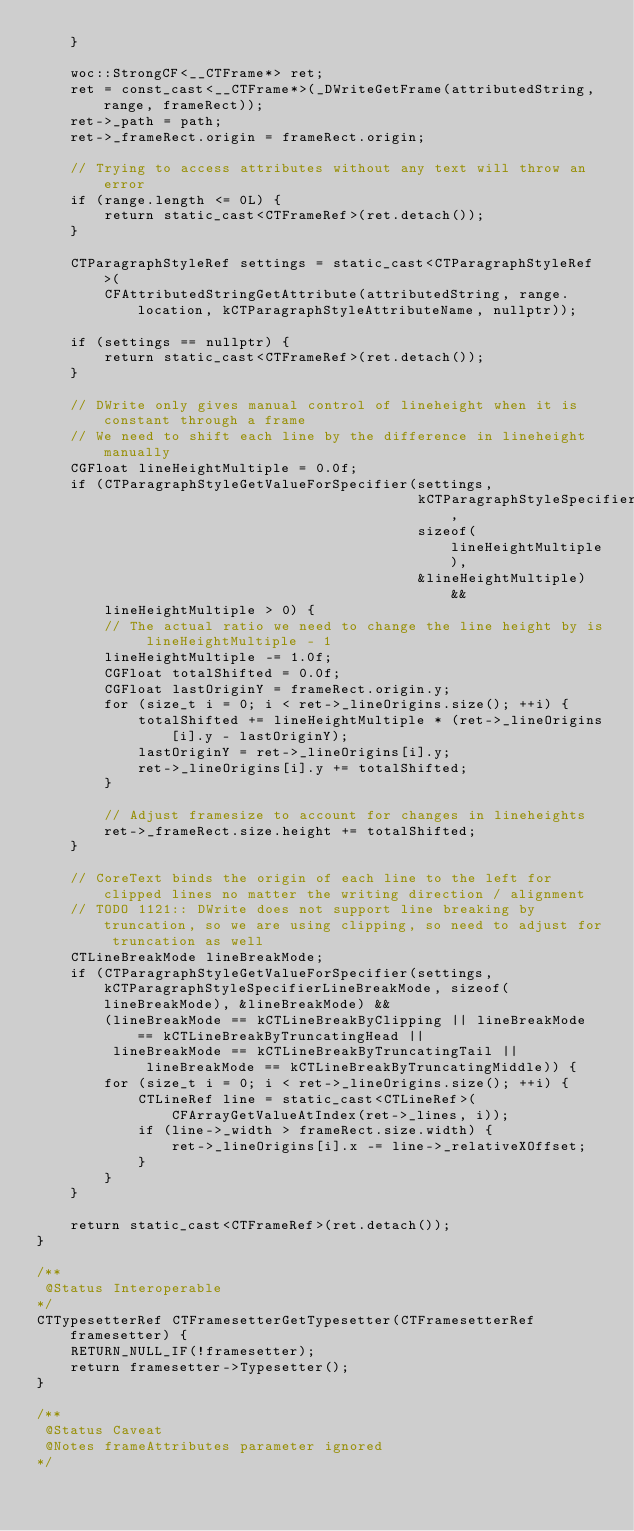Convert code to text. <code><loc_0><loc_0><loc_500><loc_500><_ObjectiveC_>    }

    woc::StrongCF<__CTFrame*> ret;
    ret = const_cast<__CTFrame*>(_DWriteGetFrame(attributedString, range, frameRect));
    ret->_path = path;
    ret->_frameRect.origin = frameRect.origin;

    // Trying to access attributes without any text will throw an error
    if (range.length <= 0L) {
        return static_cast<CTFrameRef>(ret.detach());
    }

    CTParagraphStyleRef settings = static_cast<CTParagraphStyleRef>(
        CFAttributedStringGetAttribute(attributedString, range.location, kCTParagraphStyleAttributeName, nullptr));

    if (settings == nullptr) {
        return static_cast<CTFrameRef>(ret.detach());
    }

    // DWrite only gives manual control of lineheight when it is constant through a frame
    // We need to shift each line by the difference in lineheight manually
    CGFloat lineHeightMultiple = 0.0f;
    if (CTParagraphStyleGetValueForSpecifier(settings,
                                             kCTParagraphStyleSpecifierLineHeightMultiple,
                                             sizeof(lineHeightMultiple),
                                             &lineHeightMultiple) &&
        lineHeightMultiple > 0) {
        // The actual ratio we need to change the line height by is lineHeightMultiple - 1
        lineHeightMultiple -= 1.0f;
        CGFloat totalShifted = 0.0f;
        CGFloat lastOriginY = frameRect.origin.y;
        for (size_t i = 0; i < ret->_lineOrigins.size(); ++i) {
            totalShifted += lineHeightMultiple * (ret->_lineOrigins[i].y - lastOriginY);
            lastOriginY = ret->_lineOrigins[i].y;
            ret->_lineOrigins[i].y += totalShifted;
        }

        // Adjust framesize to account for changes in lineheights
        ret->_frameRect.size.height += totalShifted;
    }

    // CoreText binds the origin of each line to the left for clipped lines no matter the writing direction / alignment
    // TODO 1121:: DWrite does not support line breaking by truncation, so we are using clipping, so need to adjust for truncation as well
    CTLineBreakMode lineBreakMode;
    if (CTParagraphStyleGetValueForSpecifier(settings, kCTParagraphStyleSpecifierLineBreakMode, sizeof(lineBreakMode), &lineBreakMode) &&
        (lineBreakMode == kCTLineBreakByClipping || lineBreakMode == kCTLineBreakByTruncatingHead ||
         lineBreakMode == kCTLineBreakByTruncatingTail || lineBreakMode == kCTLineBreakByTruncatingMiddle)) {
        for (size_t i = 0; i < ret->_lineOrigins.size(); ++i) {
            CTLineRef line = static_cast<CTLineRef>(CFArrayGetValueAtIndex(ret->_lines, i));
            if (line->_width > frameRect.size.width) {
                ret->_lineOrigins[i].x -= line->_relativeXOffset;
            }
        }
    }

    return static_cast<CTFrameRef>(ret.detach());
}

/**
 @Status Interoperable
*/
CTTypesetterRef CTFramesetterGetTypesetter(CTFramesetterRef framesetter) {
    RETURN_NULL_IF(!framesetter);
    return framesetter->Typesetter();
}

/**
 @Status Caveat
 @Notes frameAttributes parameter ignored
*/</code> 